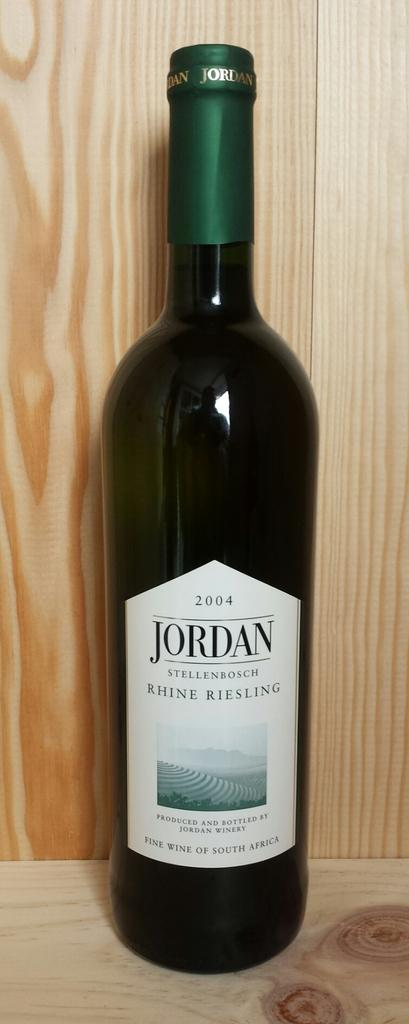<image>
Summarize the visual content of the image. a 2004 bottle of jordan stellenbosch rhine riesling 